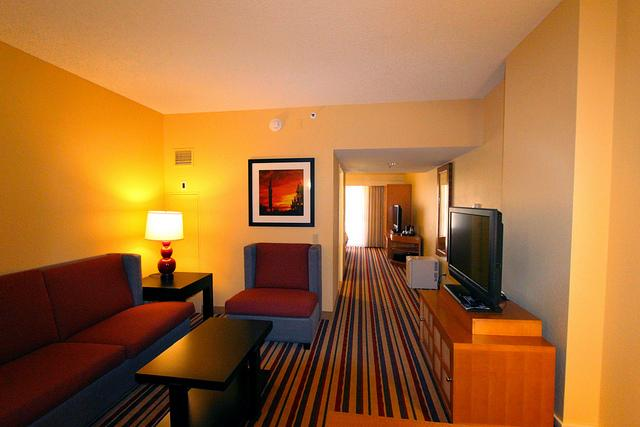What can be done with the appliance in this room?

Choices:
A) cooling
B) cooking
C) washing
D) viewing viewing 